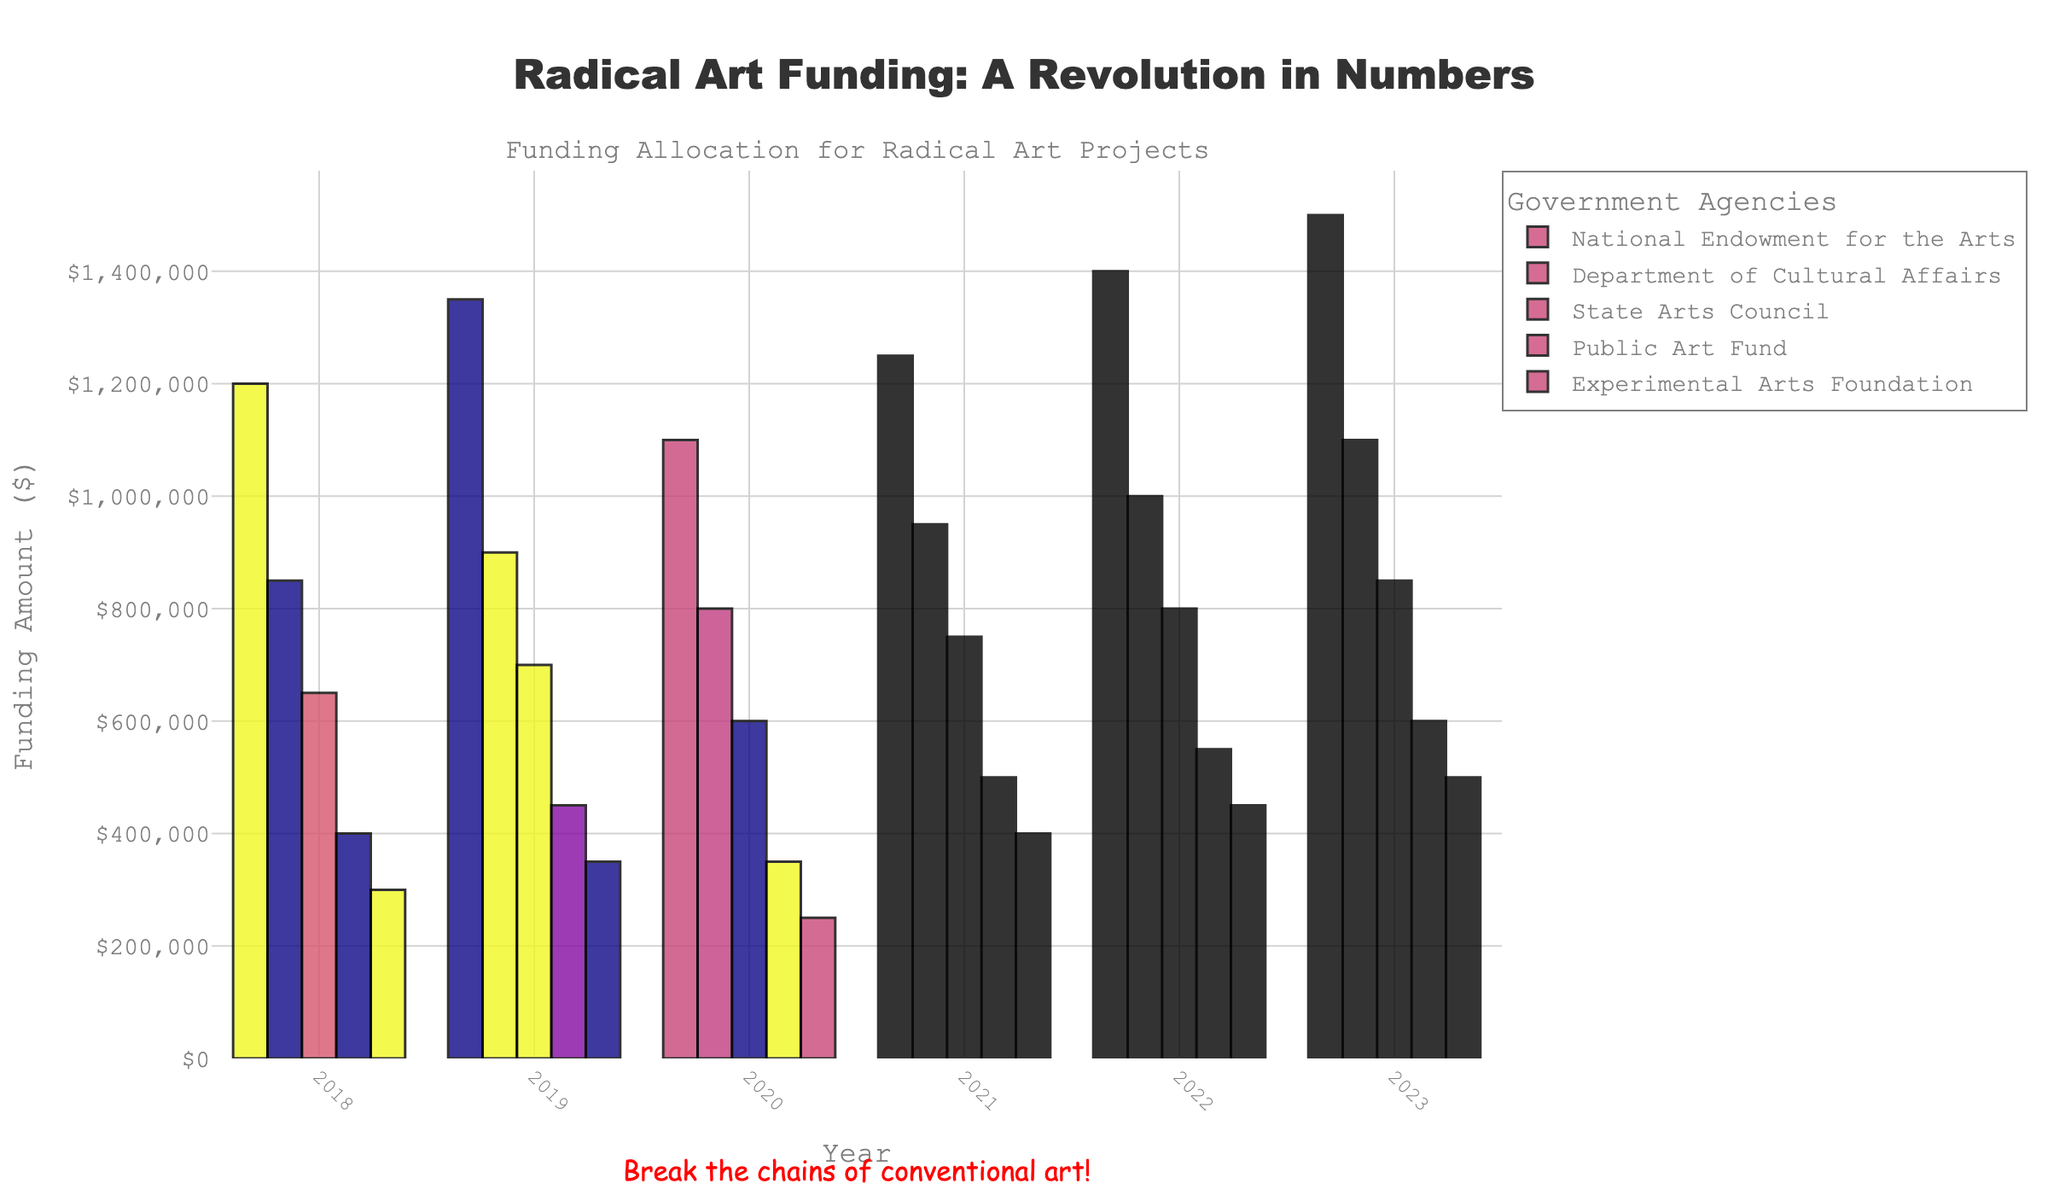What was the funding amount for the National Endowment for the Arts in 2020? To find this, locate the bar for National Endowment for the Arts in 2020 and read the value on the y-axis.
Answer: 1100000 Which agency received the highest funding in 2023? Look at the bars for 2023 and identify the tallest one. This bar represents the agency with the highest funding.
Answer: National Endowment for the Arts Compare the funding trend of the National Endowment for the Arts and the Experimental Arts Foundation from 2018 to 2023. Which one shows a more consistent increase? Observe the bars for both agencies across the years. The Experimental Arts Foundation shows a steadier increase without any drops, while the National Endowment for the Arts has a slight dip in 2020.
Answer: Experimental Arts Foundation By how much did the funding for the Department of Cultural Affairs increase from 2019 to 2022? Subtract the funding amount in 2019 from the amount in 2022 for the Department of Cultural Affairs. 1000000 - 900000 = 100000.
Answer: 100000 Which year saw the highest combined funding for all agencies? Sum the heights of all bars for each year. Calculate and compare the totals to find the highest one. 2018: 1200000+850000+650000+400000+300000 = 3400000; 2019: 1350000+900000+700000+450000+350000 = 3750000; 2020: 1100000+800000+600000+350000+250000 = 3100000; 2021: 1250000+950000+750000+500000+400000 = 3850000; 2022: 1400000+1000000+800000+550000+450000 = 4250000; 2023: 1500000+1100000+850000+600000+500000 = 4550000.
Answer: 2023 What is the difference in funding for the State Arts Council between 2018 and 2021? Subtract the 2018 funding from the 2021 funding for the State Arts Council. 750000 - 650000 = 100000.
Answer: 100000 Which agency had the smallest increase in funding from 2018 to 2023? Calculate the increase in funding for each agency from 2018 to 2023 and compare the values. The Experimental Arts Foundation increased from 300000 to 500000, a difference of 200000.
Answer: Experimental Arts Foundation What is the percentage increase in funding for Public Art Fund from 2018 to 2023? Calculate the percentage increase using the formula ((new amount - old amount)/old amount) * 100. ((600000 - 400000)/400000) * 100 = 50%.
Answer: 50% Which agency experienced a decrease in funding in 2020, and what was the amount of the decrease? Identify the agencies with a lower funding amount in 2020 compared to 2019 and calculate the difference. National Endowment for the Arts: 1350000 - 1100000 = 250000.
Answer: National Endowment for the Arts, 250000 